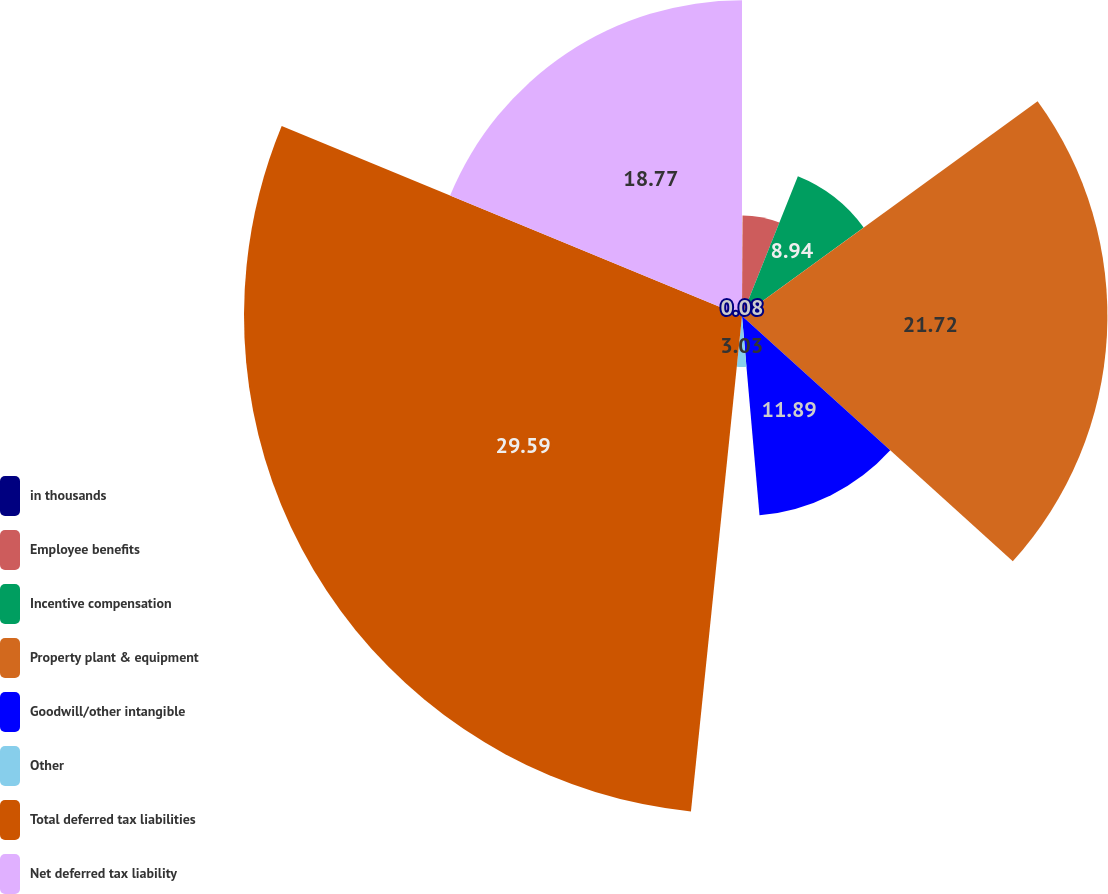<chart> <loc_0><loc_0><loc_500><loc_500><pie_chart><fcel>in thousands<fcel>Employee benefits<fcel>Incentive compensation<fcel>Property plant & equipment<fcel>Goodwill/other intangible<fcel>Other<fcel>Total deferred tax liabilities<fcel>Net deferred tax liability<nl><fcel>0.08%<fcel>5.98%<fcel>8.94%<fcel>21.72%<fcel>11.89%<fcel>3.03%<fcel>29.6%<fcel>18.77%<nl></chart> 